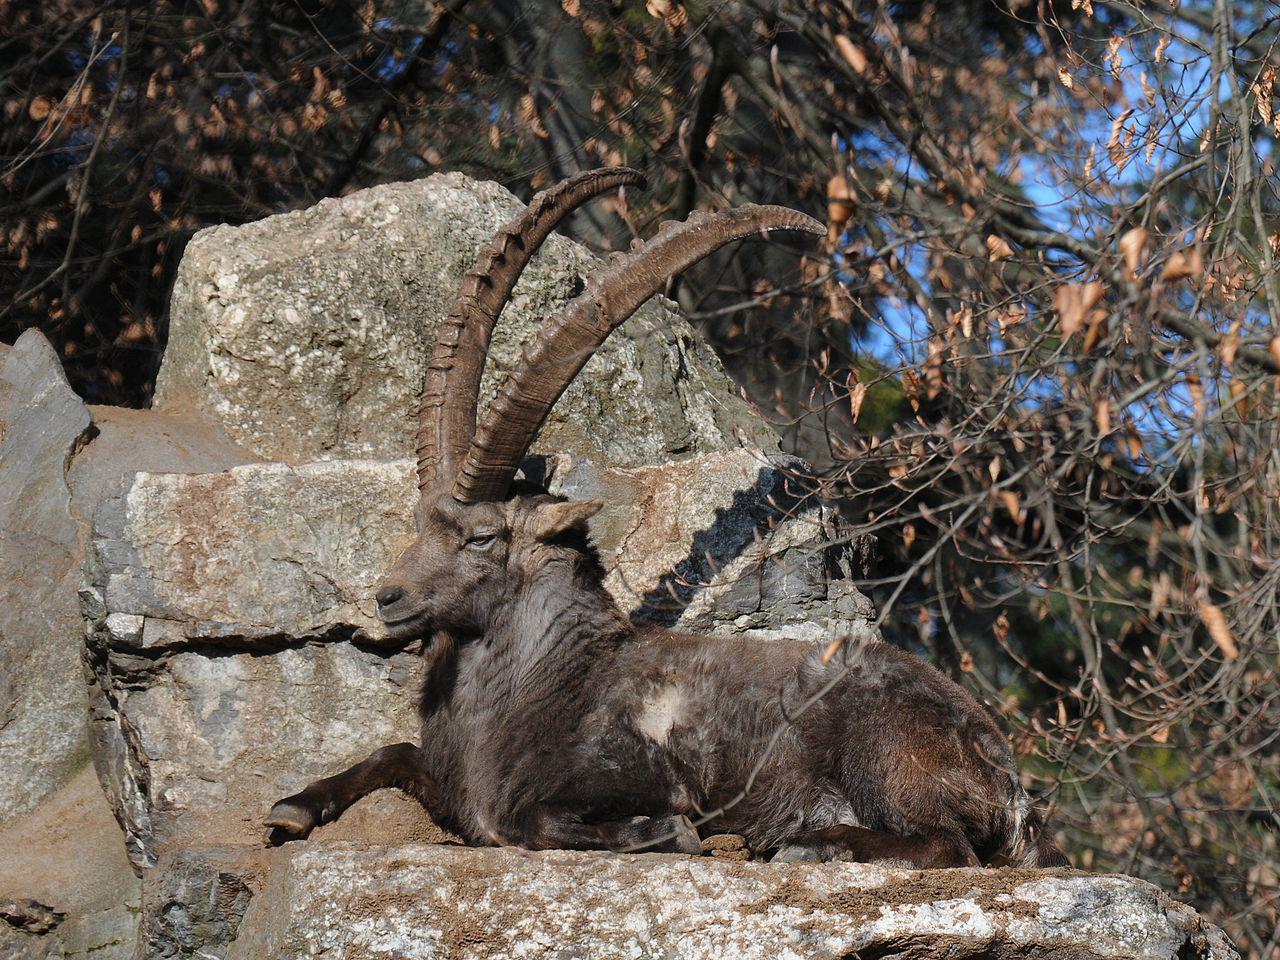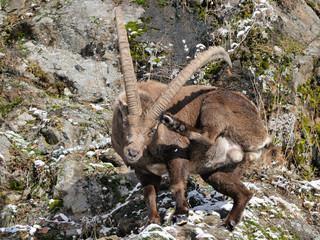The first image is the image on the left, the second image is the image on the right. Assess this claim about the two images: "There are exactly four animals in the image on the left.". Correct or not? Answer yes or no. No. 